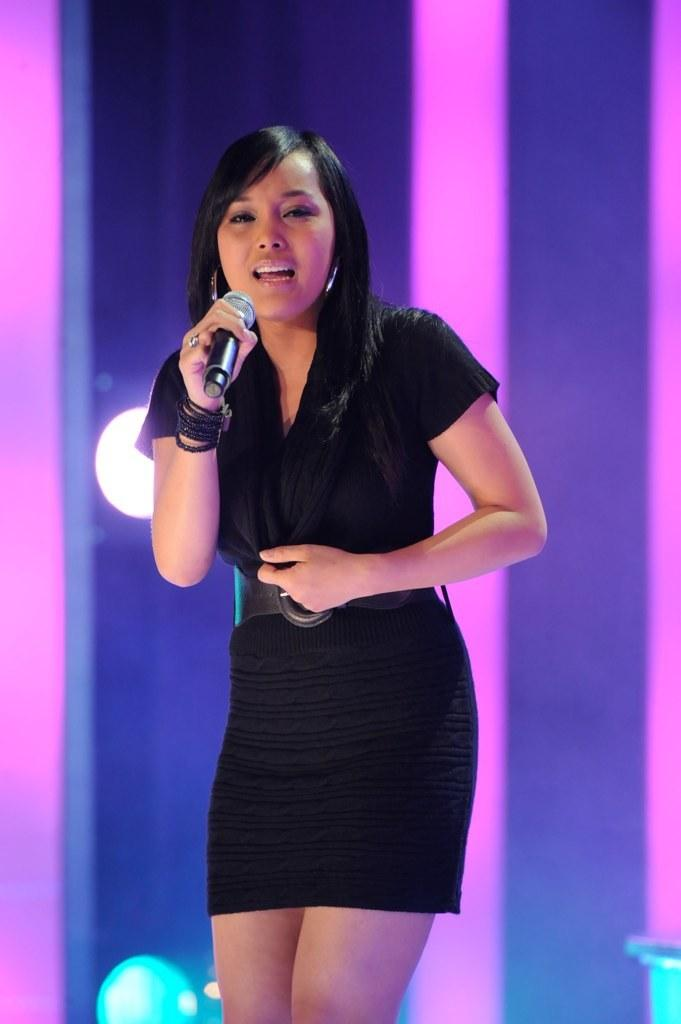Who is the main subject in the image? There is a woman in the image. What is the woman wearing? The woman is wearing a black dress. What is the woman holding in the image? The woman is holding a microphone. What activity is the woman engaged in? The woman is singing, as indicated by her open mouth. What can be seen in the background of the image? There is a light in the background of the image. How many pets are visible in the image? There are no pets present in the image. What type of room is the woman singing in? The provided facts do not give any information about the room or its type. 